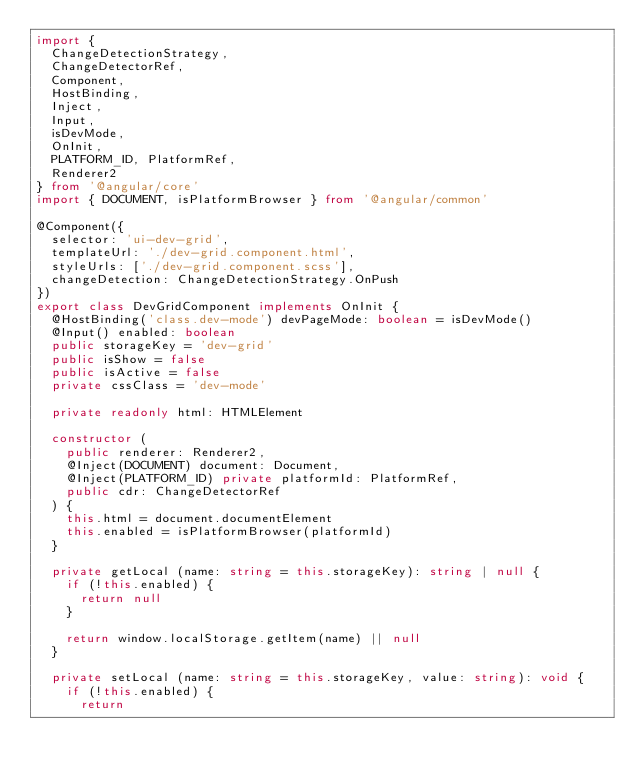Convert code to text. <code><loc_0><loc_0><loc_500><loc_500><_TypeScript_>import {
  ChangeDetectionStrategy,
  ChangeDetectorRef,
  Component,
  HostBinding,
  Inject,
  Input,
  isDevMode,
  OnInit,
  PLATFORM_ID, PlatformRef,
  Renderer2
} from '@angular/core'
import { DOCUMENT, isPlatformBrowser } from '@angular/common'

@Component({
  selector: 'ui-dev-grid',
  templateUrl: './dev-grid.component.html',
  styleUrls: ['./dev-grid.component.scss'],
  changeDetection: ChangeDetectionStrategy.OnPush
})
export class DevGridComponent implements OnInit {
  @HostBinding('class.dev-mode') devPageMode: boolean = isDevMode()
  @Input() enabled: boolean
  public storageKey = 'dev-grid'
  public isShow = false
  public isActive = false
  private cssClass = 'dev-mode'

  private readonly html: HTMLElement

  constructor (
    public renderer: Renderer2,
    @Inject(DOCUMENT) document: Document,
    @Inject(PLATFORM_ID) private platformId: PlatformRef,
    public cdr: ChangeDetectorRef
  ) {
    this.html = document.documentElement
    this.enabled = isPlatformBrowser(platformId)
  }

  private getLocal (name: string = this.storageKey): string | null {
    if (!this.enabled) {
      return null
    }

    return window.localStorage.getItem(name) || null
  }

  private setLocal (name: string = this.storageKey, value: string): void {
    if (!this.enabled) {
      return</code> 